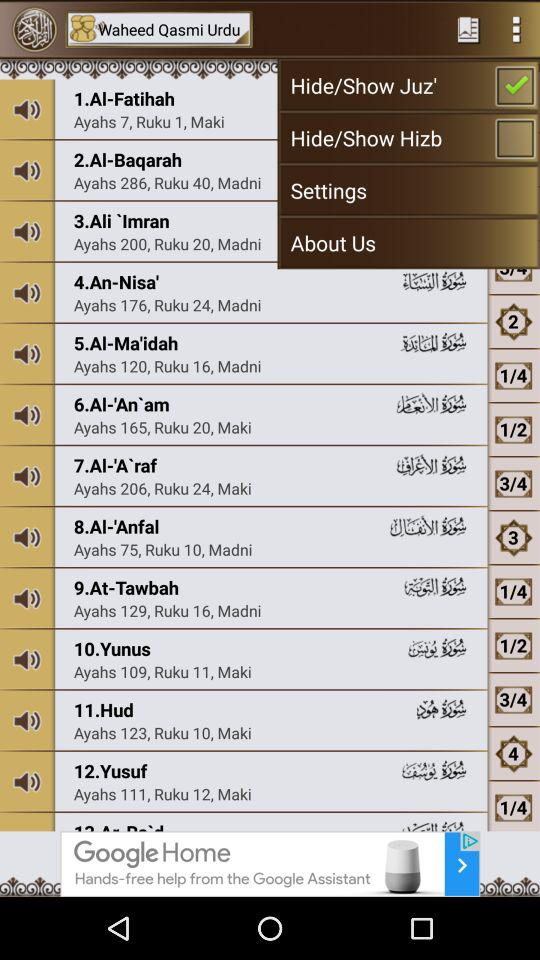How many Ruku are there in "Hud"? There are 10 Rukus in "Hud". 